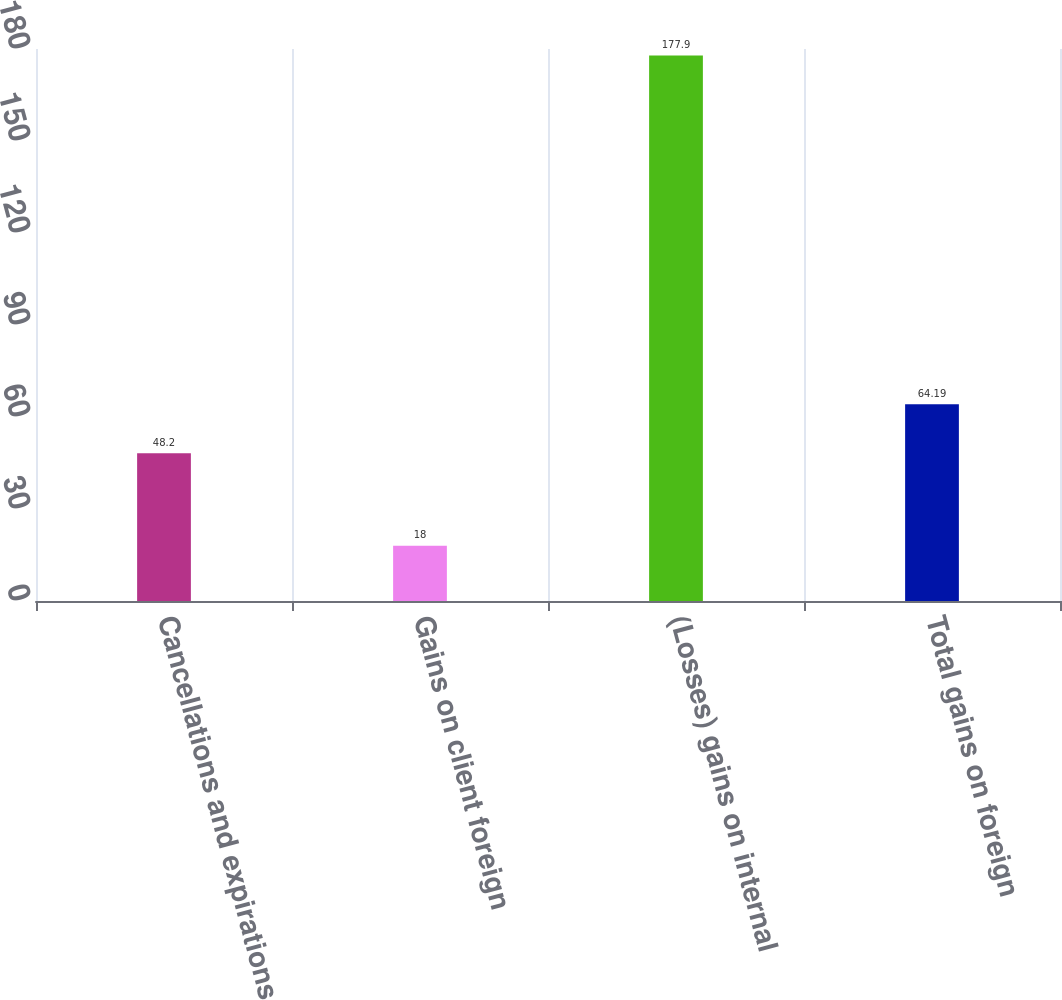Convert chart. <chart><loc_0><loc_0><loc_500><loc_500><bar_chart><fcel>Cancellations and expirations<fcel>Gains on client foreign<fcel>(Losses) gains on internal<fcel>Total gains on foreign<nl><fcel>48.2<fcel>18<fcel>177.9<fcel>64.19<nl></chart> 